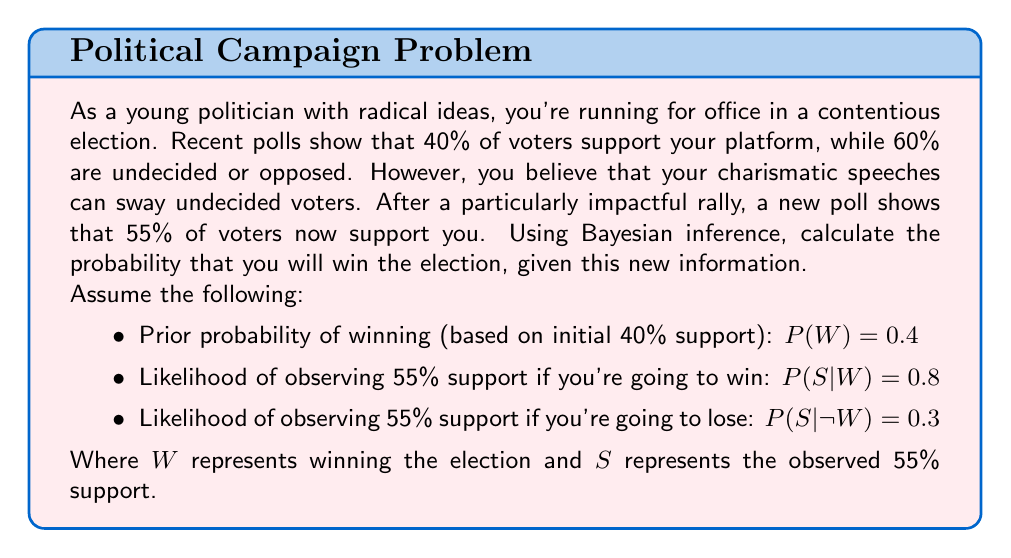Can you answer this question? To solve this problem, we'll use Bayes' theorem:

$$P(W|S) = \frac{P(S|W) \cdot P(W)}{P(S)}$$

Where $P(W|S)$ is the posterior probability of winning given the new poll results.

Step 1: Calculate $P(S)$ using the law of total probability:
$$P(S) = P(S|W) \cdot P(W) + P(S|\neg W) \cdot P(\neg W)$$
$$P(S) = 0.8 \cdot 0.4 + 0.3 \cdot (1 - 0.4)$$
$$P(S) = 0.32 + 0.18 = 0.5$$

Step 2: Apply Bayes' theorem:
$$P(W|S) = \frac{P(S|W) \cdot P(W)}{P(S)}$$
$$P(W|S) = \frac{0.8 \cdot 0.4}{0.5}$$
$$P(W|S) = \frac{0.32}{0.5} = 0.64$$

Therefore, given the new poll results showing 55% support, the probability of winning the election is 0.64 or 64%.

This result demonstrates how Bayesian inference can update our beliefs based on new evidence. The initial probability of winning was 40%, but after incorporating the new poll results, the probability increased to 64%, reflecting the positive impact of the recent rally on your election prospects.
Answer: The probability of winning the election, given the new poll results, is 0.64 or 64%. 